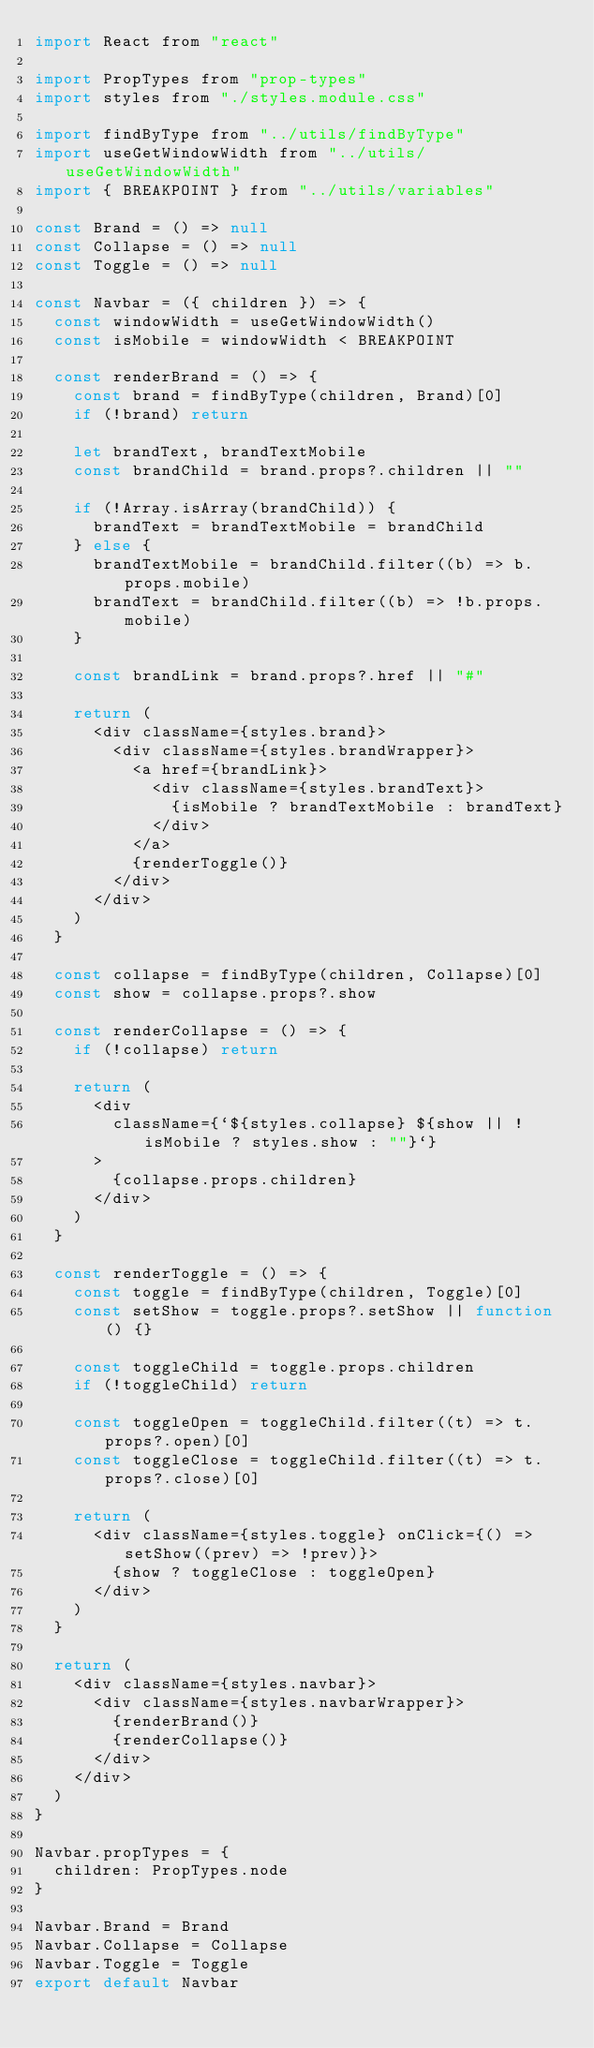Convert code to text. <code><loc_0><loc_0><loc_500><loc_500><_JavaScript_>import React from "react"

import PropTypes from "prop-types"
import styles from "./styles.module.css"

import findByType from "../utils/findByType"
import useGetWindowWidth from "../utils/useGetWindowWidth"
import { BREAKPOINT } from "../utils/variables"

const Brand = () => null
const Collapse = () => null
const Toggle = () => null

const Navbar = ({ children }) => {
  const windowWidth = useGetWindowWidth()
  const isMobile = windowWidth < BREAKPOINT

  const renderBrand = () => {
    const brand = findByType(children, Brand)[0]
    if (!brand) return

    let brandText, brandTextMobile
    const brandChild = brand.props?.children || ""

    if (!Array.isArray(brandChild)) {
      brandText = brandTextMobile = brandChild
    } else {
      brandTextMobile = brandChild.filter((b) => b.props.mobile)
      brandText = brandChild.filter((b) => !b.props.mobile)
    }

    const brandLink = brand.props?.href || "#"

    return (
      <div className={styles.brand}>
        <div className={styles.brandWrapper}>
          <a href={brandLink}>
            <div className={styles.brandText}>
              {isMobile ? brandTextMobile : brandText}
            </div>
          </a>
          {renderToggle()}
        </div>
      </div>
    )
  }

  const collapse = findByType(children, Collapse)[0]
  const show = collapse.props?.show

  const renderCollapse = () => {
    if (!collapse) return

    return (
      <div
        className={`${styles.collapse} ${show || !isMobile ? styles.show : ""}`}
      >
        {collapse.props.children}
      </div>
    )
  }

  const renderToggle = () => {
    const toggle = findByType(children, Toggle)[0]
    const setShow = toggle.props?.setShow || function() {}

    const toggleChild = toggle.props.children
    if (!toggleChild) return

    const toggleOpen = toggleChild.filter((t) => t.props?.open)[0]
    const toggleClose = toggleChild.filter((t) => t.props?.close)[0]

    return (
      <div className={styles.toggle} onClick={() => setShow((prev) => !prev)}>
        {show ? toggleClose : toggleOpen}
      </div>
    )
  }

  return (
    <div className={styles.navbar}>
      <div className={styles.navbarWrapper}>
        {renderBrand()}
        {renderCollapse()}
      </div>
    </div>
  )
}

Navbar.propTypes = {
  children: PropTypes.node
}

Navbar.Brand = Brand
Navbar.Collapse = Collapse
Navbar.Toggle = Toggle
export default Navbar
</code> 